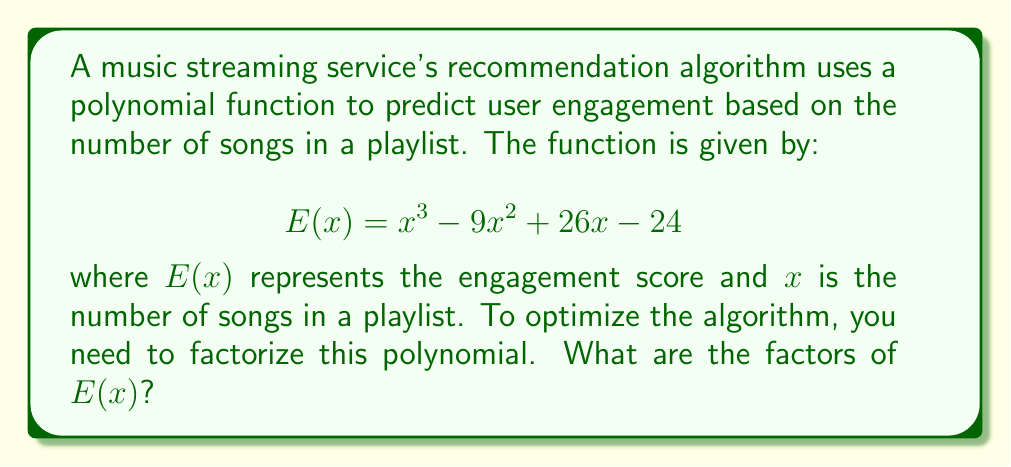Could you help me with this problem? Let's factorize the polynomial $E(x) = x^3 - 9x^2 + 26x - 24$ step by step:

1) First, let's check if there are any rational roots using the rational root theorem. The possible rational roots are the factors of the constant term (24): ±1, ±2, ±3, ±4, ±6, ±8, ±12, ±24.

2) Testing these values, we find that $x = 2$ is a root of the polynomial. This means $(x - 2)$ is a factor.

3) We can use polynomial long division to divide $E(x)$ by $(x - 2)$:

   $$\frac{x^3 - 9x^2 + 26x - 24}{x - 2} = x^2 - 7x + 12$$

4) Now we have: $E(x) = (x - 2)(x^2 - 7x + 12)$

5) The quadratic factor $x^2 - 7x + 12$ can be further factored:
   
   $$x^2 - 7x + 12 = (x - 3)(x - 4)$$

6) Therefore, the complete factorization is:

   $$E(x) = (x - 2)(x - 3)(x - 4)$$

This factorization reveals that the engagement score will be zero when the playlist has 2, 3, or 4 songs, which could be valuable information for optimizing the recommendation algorithm.
Answer: $(x - 2)(x - 3)(x - 4)$ 